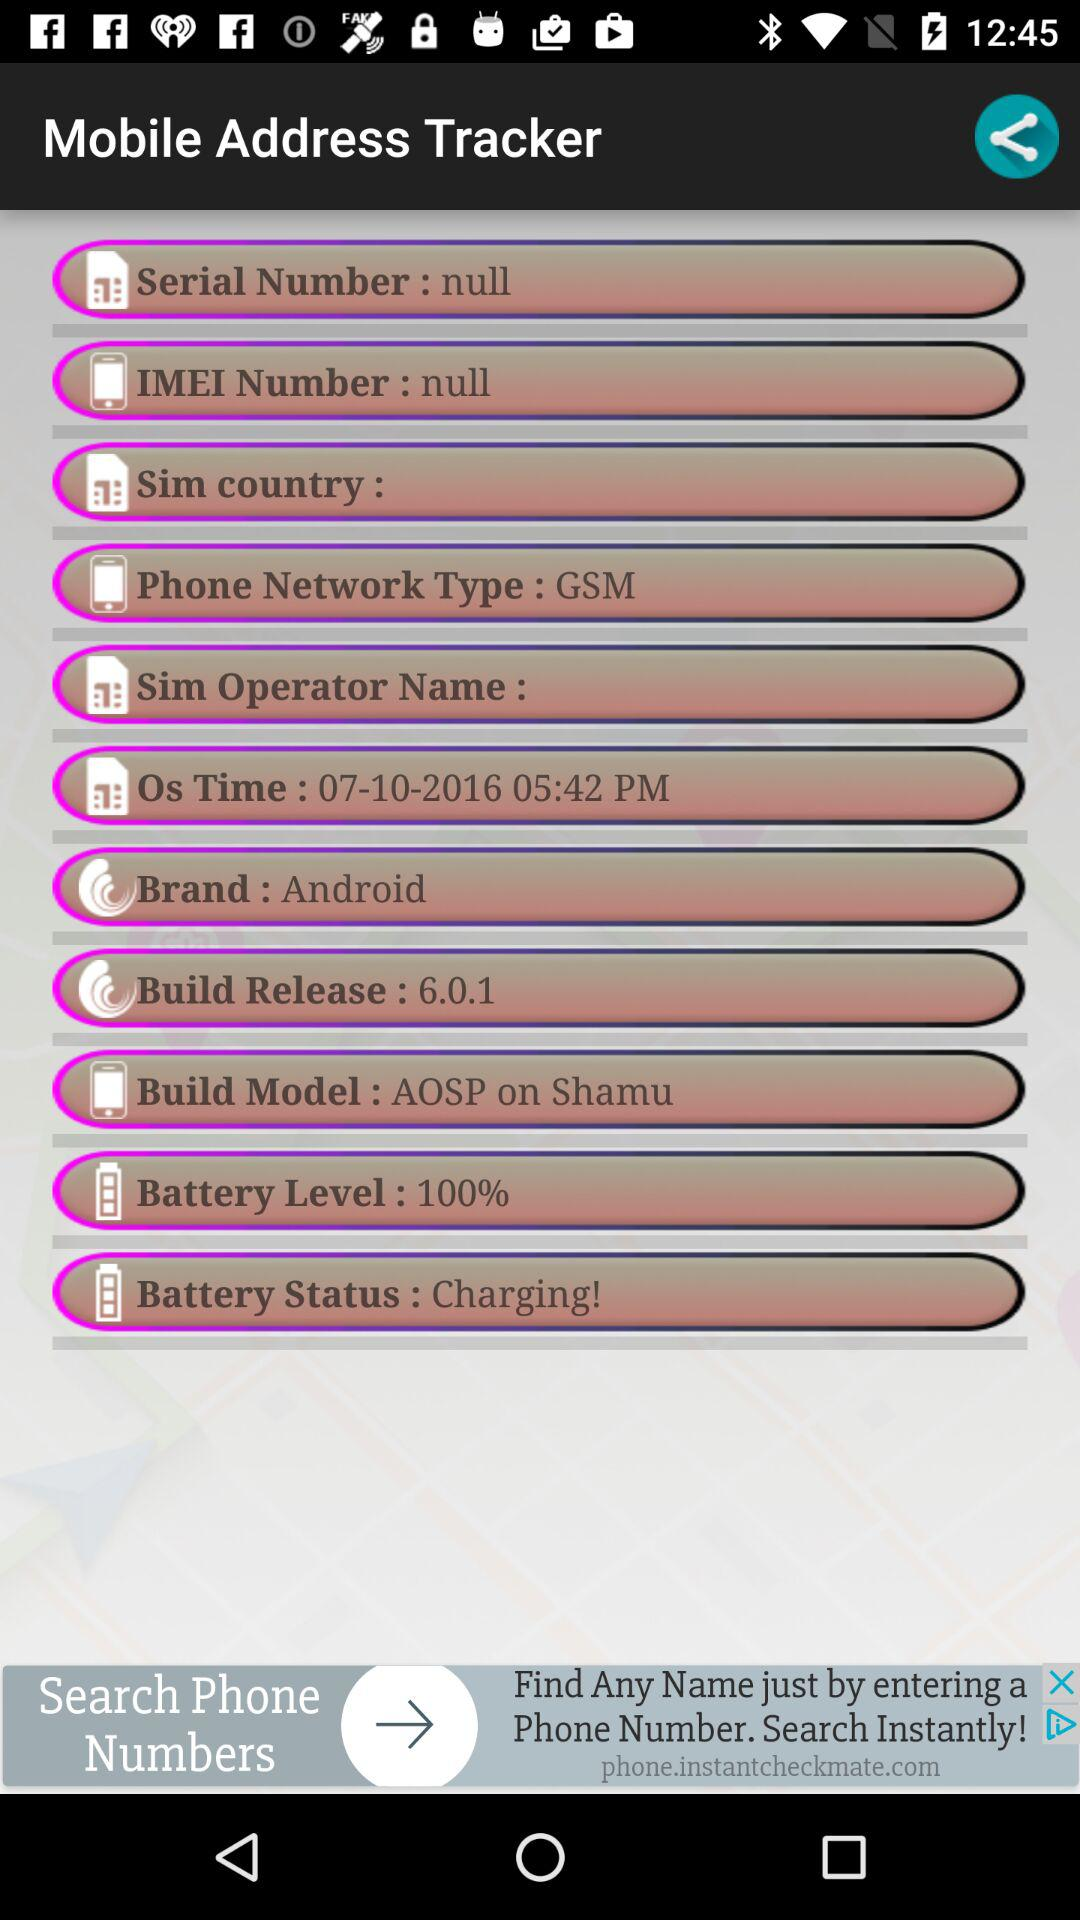What is the "Build Model" of the tracker? The "Build Model" of the tracker is "AOSP on Shamu". 